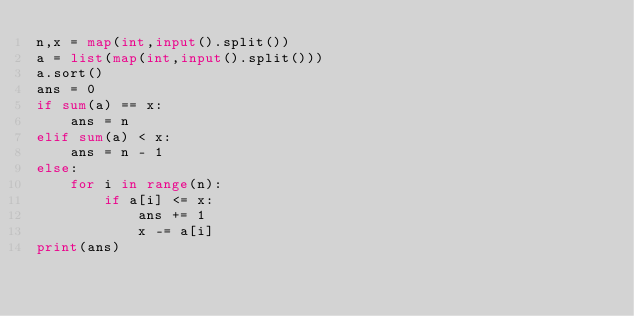Convert code to text. <code><loc_0><loc_0><loc_500><loc_500><_Python_>n,x = map(int,input().split())
a = list(map(int,input().split()))
a.sort()
ans = 0
if sum(a) == x:
    ans = n
elif sum(a) < x:
    ans = n - 1
else:
    for i in range(n):
        if a[i] <= x:
            ans += 1
            x -= a[i]
print(ans)
</code> 